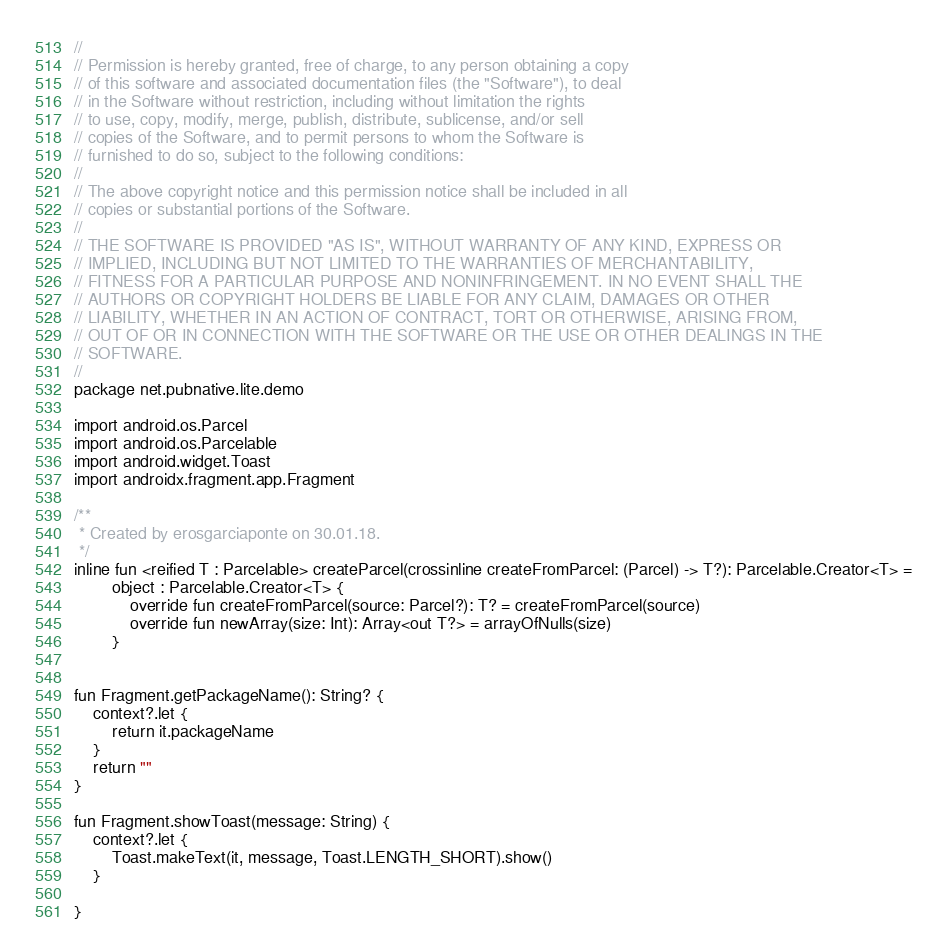<code> <loc_0><loc_0><loc_500><loc_500><_Kotlin_>//
// Permission is hereby granted, free of charge, to any person obtaining a copy
// of this software and associated documentation files (the "Software"), to deal
// in the Software without restriction, including without limitation the rights
// to use, copy, modify, merge, publish, distribute, sublicense, and/or sell
// copies of the Software, and to permit persons to whom the Software is
// furnished to do so, subject to the following conditions:
//
// The above copyright notice and this permission notice shall be included in all
// copies or substantial portions of the Software.
//
// THE SOFTWARE IS PROVIDED "AS IS", WITHOUT WARRANTY OF ANY KIND, EXPRESS OR
// IMPLIED, INCLUDING BUT NOT LIMITED TO THE WARRANTIES OF MERCHANTABILITY,
// FITNESS FOR A PARTICULAR PURPOSE AND NONINFRINGEMENT. IN NO EVENT SHALL THE
// AUTHORS OR COPYRIGHT HOLDERS BE LIABLE FOR ANY CLAIM, DAMAGES OR OTHER
// LIABILITY, WHETHER IN AN ACTION OF CONTRACT, TORT OR OTHERWISE, ARISING FROM,
// OUT OF OR IN CONNECTION WITH THE SOFTWARE OR THE USE OR OTHER DEALINGS IN THE
// SOFTWARE.
//
package net.pubnative.lite.demo

import android.os.Parcel
import android.os.Parcelable
import android.widget.Toast
import androidx.fragment.app.Fragment

/**
 * Created by erosgarciaponte on 30.01.18.
 */
inline fun <reified T : Parcelable> createParcel(crossinline createFromParcel: (Parcel) -> T?): Parcelable.Creator<T> =
        object : Parcelable.Creator<T> {
            override fun createFromParcel(source: Parcel?): T? = createFromParcel(source)
            override fun newArray(size: Int): Array<out T?> = arrayOfNulls(size)
        }


fun Fragment.getPackageName(): String? {
    context?.let {
        return it.packageName
    }
    return ""
}

fun Fragment.showToast(message: String) {
    context?.let {
        Toast.makeText(it, message, Toast.LENGTH_SHORT).show()
    }

}</code> 